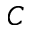Convert formula to latex. <formula><loc_0><loc_0><loc_500><loc_500>C</formula> 